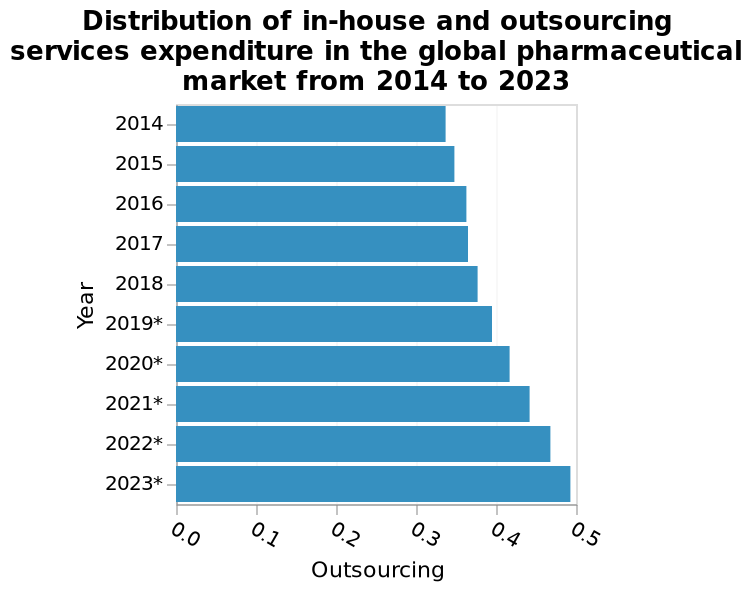<image>
What is the subject of analysis in the global pharmaceutical market? The subject of analysis in the global pharmaceutical market is the expenditure on in-house and outsourcing services. What is defined along the x-axis of the bar plot? Outsourcing is defined along the x-axis of the bar plot. What can be inferred about the expenditure trend in the global pharmaceutical market based on the graph? The graph suggests a steady expenditure for the global pharmaceutical market from 2014 to 2023. 